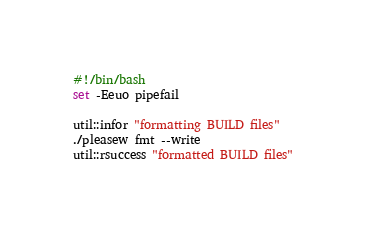<code> <loc_0><loc_0><loc_500><loc_500><_Bash_>#!/bin/bash
set -Eeuo pipefail

util::infor "formatting BUILD files"
./pleasew fmt --write
util::rsuccess "formatted BUILD files"</code> 